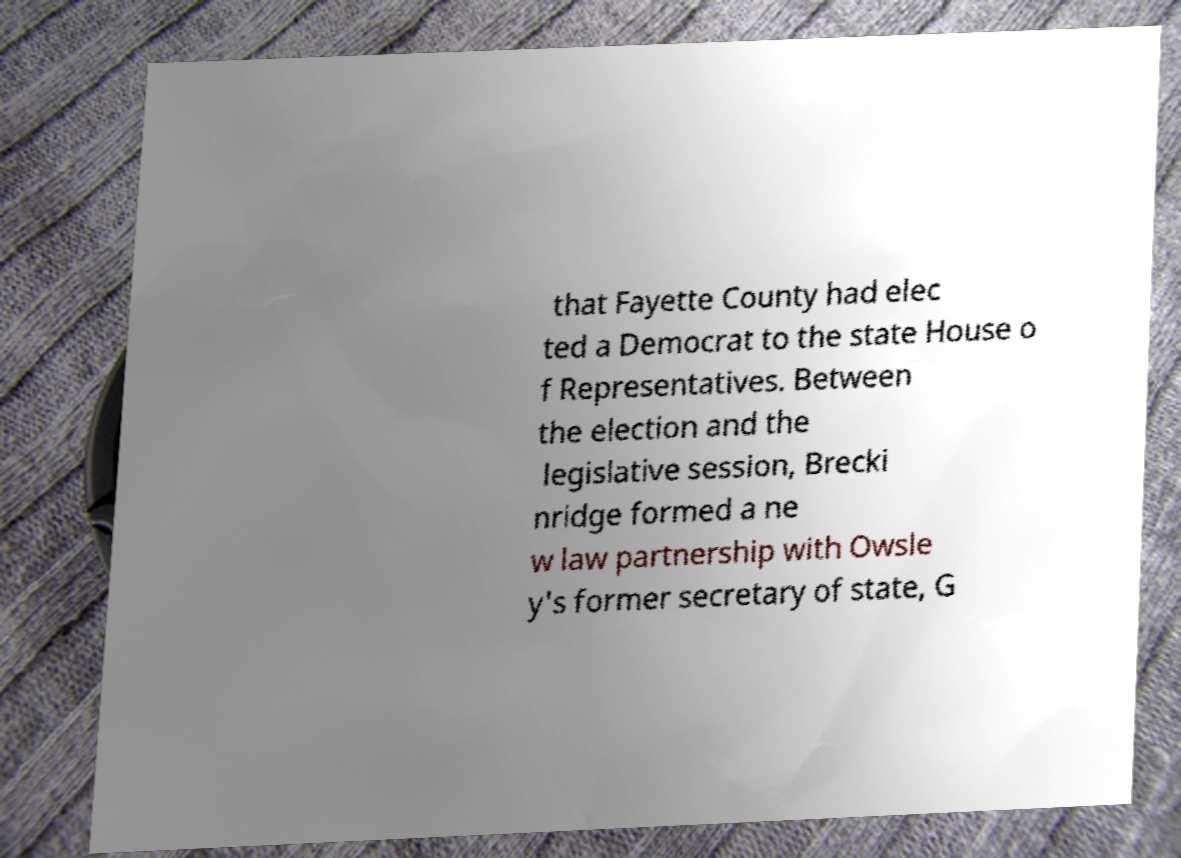Could you assist in decoding the text presented in this image and type it out clearly? that Fayette County had elec ted a Democrat to the state House o f Representatives. Between the election and the legislative session, Brecki nridge formed a ne w law partnership with Owsle y's former secretary of state, G 